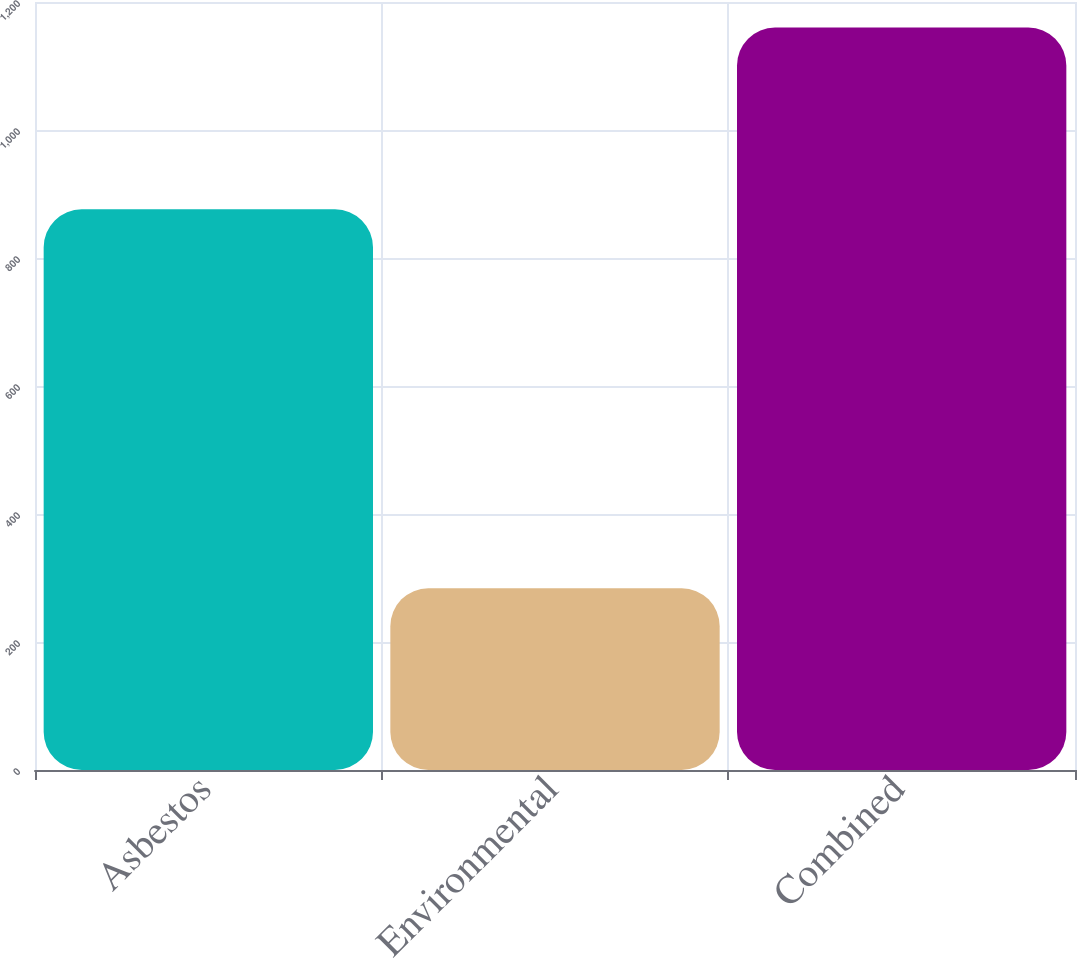<chart> <loc_0><loc_0><loc_500><loc_500><bar_chart><fcel>Asbestos<fcel>Environmental<fcel>Combined<nl><fcel>876<fcel>284<fcel>1160<nl></chart> 